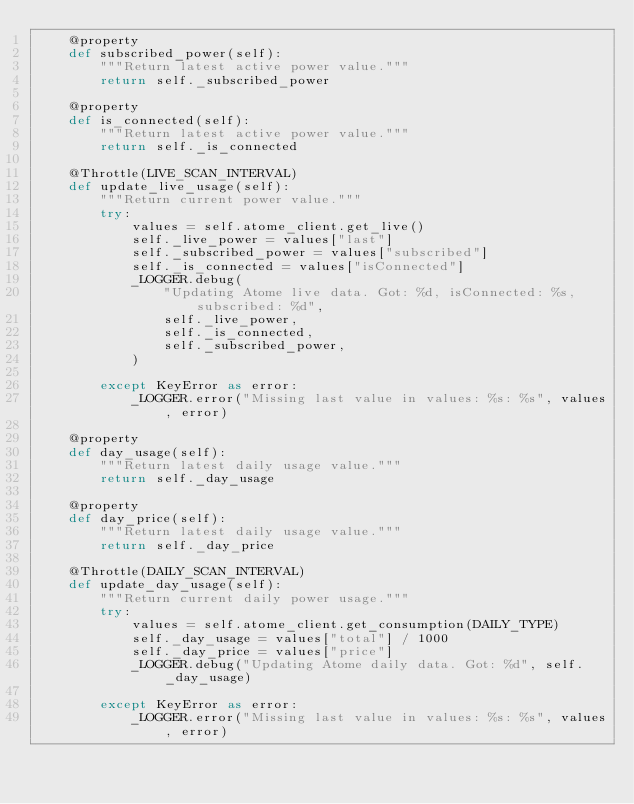<code> <loc_0><loc_0><loc_500><loc_500><_Python_>    @property
    def subscribed_power(self):
        """Return latest active power value."""
        return self._subscribed_power

    @property
    def is_connected(self):
        """Return latest active power value."""
        return self._is_connected

    @Throttle(LIVE_SCAN_INTERVAL)
    def update_live_usage(self):
        """Return current power value."""
        try:
            values = self.atome_client.get_live()
            self._live_power = values["last"]
            self._subscribed_power = values["subscribed"]
            self._is_connected = values["isConnected"]
            _LOGGER.debug(
                "Updating Atome live data. Got: %d, isConnected: %s, subscribed: %d",
                self._live_power,
                self._is_connected,
                self._subscribed_power,
            )

        except KeyError as error:
            _LOGGER.error("Missing last value in values: %s: %s", values, error)

    @property
    def day_usage(self):
        """Return latest daily usage value."""
        return self._day_usage

    @property
    def day_price(self):
        """Return latest daily usage value."""
        return self._day_price

    @Throttle(DAILY_SCAN_INTERVAL)
    def update_day_usage(self):
        """Return current daily power usage."""
        try:
            values = self.atome_client.get_consumption(DAILY_TYPE)
            self._day_usage = values["total"] / 1000
            self._day_price = values["price"]
            _LOGGER.debug("Updating Atome daily data. Got: %d", self._day_usage)

        except KeyError as error:
            _LOGGER.error("Missing last value in values: %s: %s", values, error)
</code> 